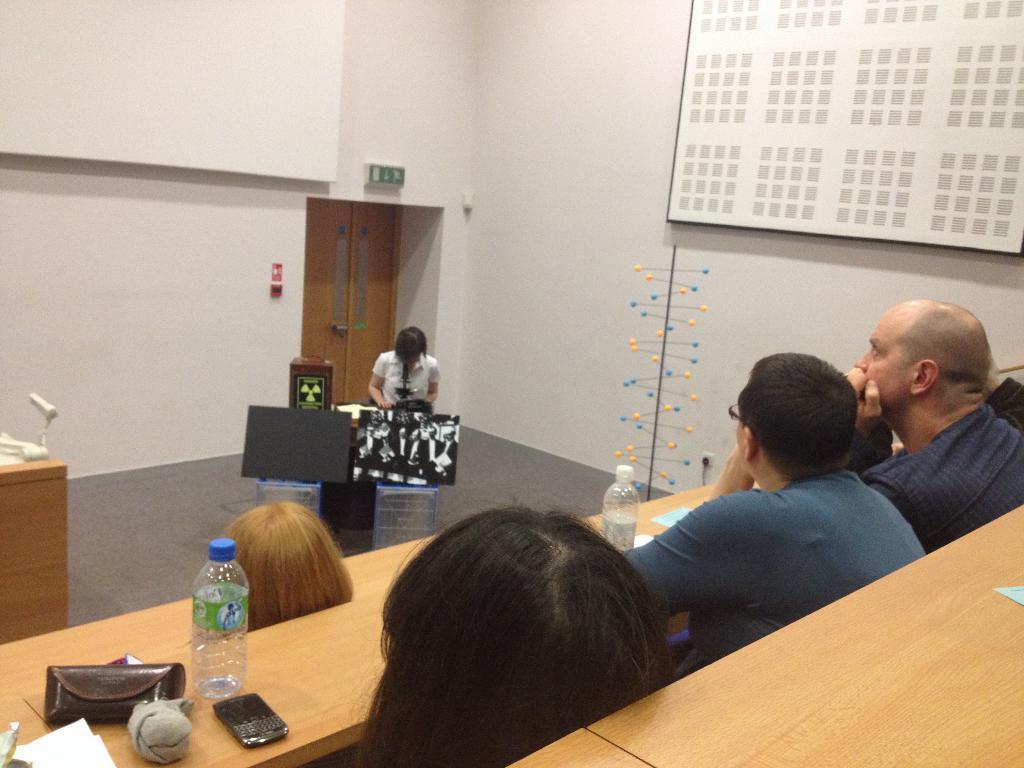Please provide a concise description of this image. In this picture, we can see a few people sitting on benches and a person standing at a podium and we can see a pole, wall with some objects and with door and we can see a table and some objects on it. 